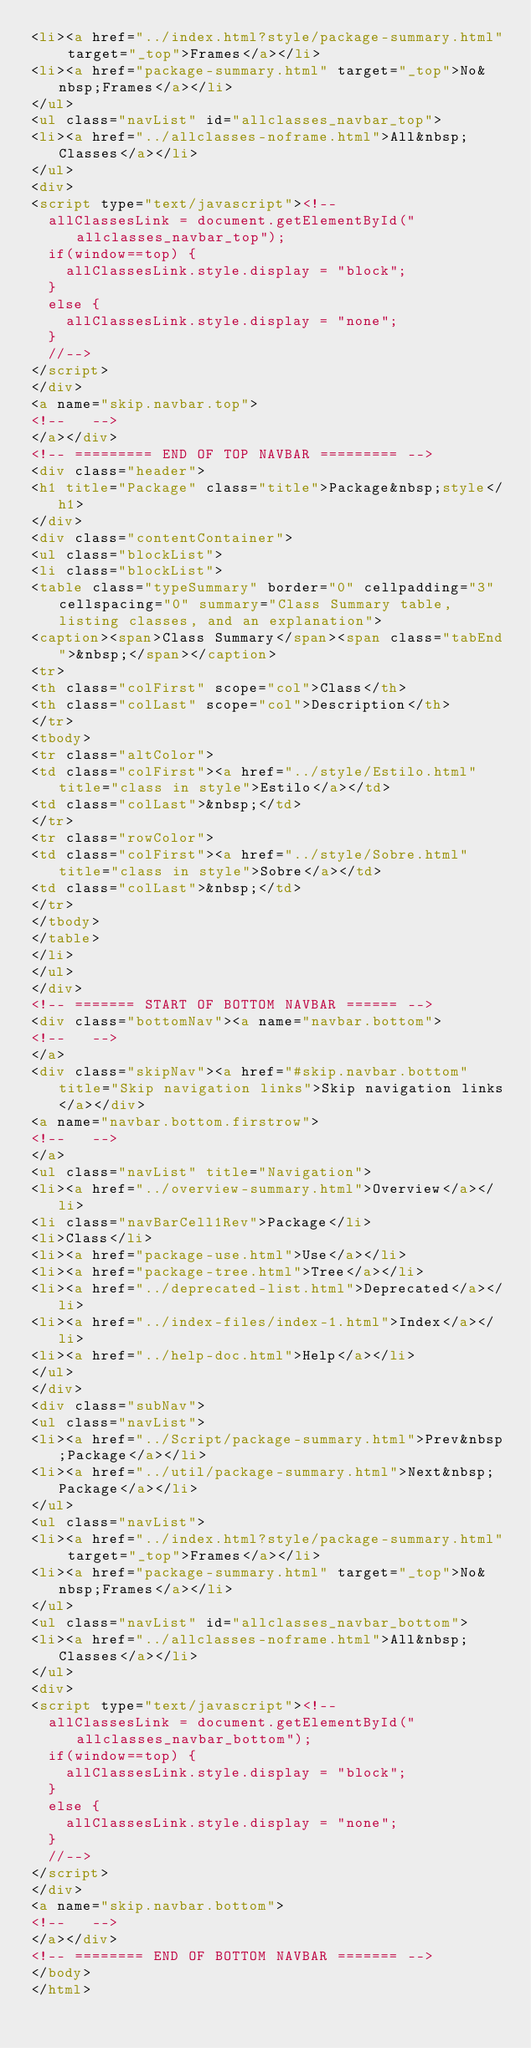Convert code to text. <code><loc_0><loc_0><loc_500><loc_500><_HTML_><li><a href="../index.html?style/package-summary.html" target="_top">Frames</a></li>
<li><a href="package-summary.html" target="_top">No&nbsp;Frames</a></li>
</ul>
<ul class="navList" id="allclasses_navbar_top">
<li><a href="../allclasses-noframe.html">All&nbsp;Classes</a></li>
</ul>
<div>
<script type="text/javascript"><!--
  allClassesLink = document.getElementById("allclasses_navbar_top");
  if(window==top) {
    allClassesLink.style.display = "block";
  }
  else {
    allClassesLink.style.display = "none";
  }
  //-->
</script>
</div>
<a name="skip.navbar.top">
<!--   -->
</a></div>
<!-- ========= END OF TOP NAVBAR ========= -->
<div class="header">
<h1 title="Package" class="title">Package&nbsp;style</h1>
</div>
<div class="contentContainer">
<ul class="blockList">
<li class="blockList">
<table class="typeSummary" border="0" cellpadding="3" cellspacing="0" summary="Class Summary table, listing classes, and an explanation">
<caption><span>Class Summary</span><span class="tabEnd">&nbsp;</span></caption>
<tr>
<th class="colFirst" scope="col">Class</th>
<th class="colLast" scope="col">Description</th>
</tr>
<tbody>
<tr class="altColor">
<td class="colFirst"><a href="../style/Estilo.html" title="class in style">Estilo</a></td>
<td class="colLast">&nbsp;</td>
</tr>
<tr class="rowColor">
<td class="colFirst"><a href="../style/Sobre.html" title="class in style">Sobre</a></td>
<td class="colLast">&nbsp;</td>
</tr>
</tbody>
</table>
</li>
</ul>
</div>
<!-- ======= START OF BOTTOM NAVBAR ====== -->
<div class="bottomNav"><a name="navbar.bottom">
<!--   -->
</a>
<div class="skipNav"><a href="#skip.navbar.bottom" title="Skip navigation links">Skip navigation links</a></div>
<a name="navbar.bottom.firstrow">
<!--   -->
</a>
<ul class="navList" title="Navigation">
<li><a href="../overview-summary.html">Overview</a></li>
<li class="navBarCell1Rev">Package</li>
<li>Class</li>
<li><a href="package-use.html">Use</a></li>
<li><a href="package-tree.html">Tree</a></li>
<li><a href="../deprecated-list.html">Deprecated</a></li>
<li><a href="../index-files/index-1.html">Index</a></li>
<li><a href="../help-doc.html">Help</a></li>
</ul>
</div>
<div class="subNav">
<ul class="navList">
<li><a href="../Script/package-summary.html">Prev&nbsp;Package</a></li>
<li><a href="../util/package-summary.html">Next&nbsp;Package</a></li>
</ul>
<ul class="navList">
<li><a href="../index.html?style/package-summary.html" target="_top">Frames</a></li>
<li><a href="package-summary.html" target="_top">No&nbsp;Frames</a></li>
</ul>
<ul class="navList" id="allclasses_navbar_bottom">
<li><a href="../allclasses-noframe.html">All&nbsp;Classes</a></li>
</ul>
<div>
<script type="text/javascript"><!--
  allClassesLink = document.getElementById("allclasses_navbar_bottom");
  if(window==top) {
    allClassesLink.style.display = "block";
  }
  else {
    allClassesLink.style.display = "none";
  }
  //-->
</script>
</div>
<a name="skip.navbar.bottom">
<!--   -->
</a></div>
<!-- ======== END OF BOTTOM NAVBAR ======= -->
</body>
</html>
</code> 